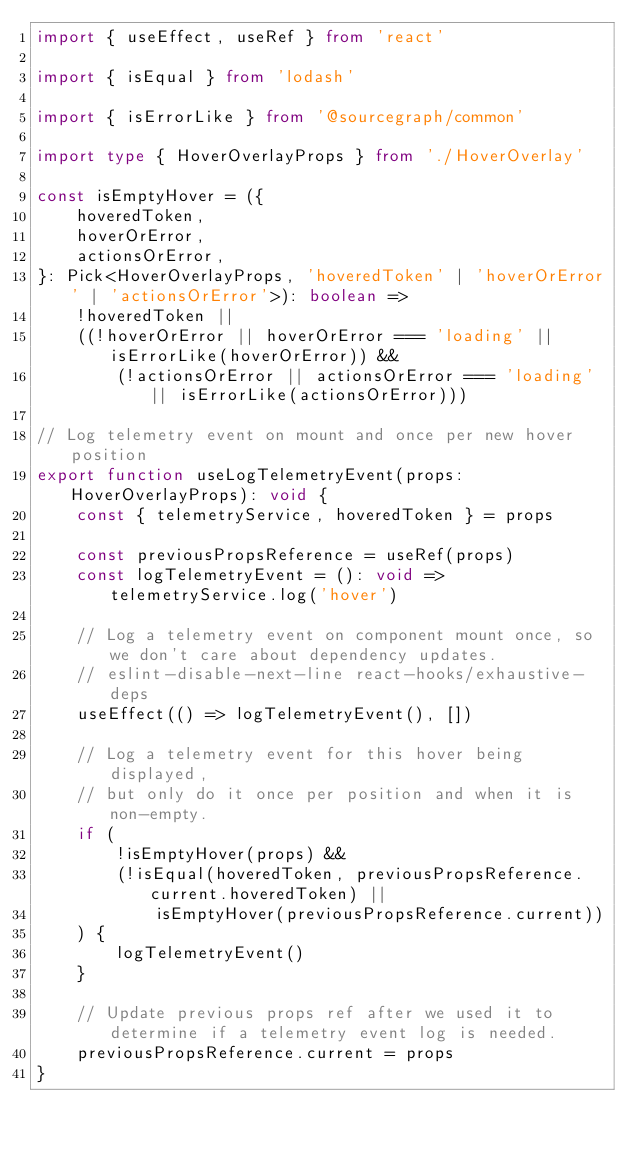Convert code to text. <code><loc_0><loc_0><loc_500><loc_500><_TypeScript_>import { useEffect, useRef } from 'react'

import { isEqual } from 'lodash'

import { isErrorLike } from '@sourcegraph/common'

import type { HoverOverlayProps } from './HoverOverlay'

const isEmptyHover = ({
    hoveredToken,
    hoverOrError,
    actionsOrError,
}: Pick<HoverOverlayProps, 'hoveredToken' | 'hoverOrError' | 'actionsOrError'>): boolean =>
    !hoveredToken ||
    ((!hoverOrError || hoverOrError === 'loading' || isErrorLike(hoverOrError)) &&
        (!actionsOrError || actionsOrError === 'loading' || isErrorLike(actionsOrError)))

// Log telemetry event on mount and once per new hover position
export function useLogTelemetryEvent(props: HoverOverlayProps): void {
    const { telemetryService, hoveredToken } = props

    const previousPropsReference = useRef(props)
    const logTelemetryEvent = (): void => telemetryService.log('hover')

    // Log a telemetry event on component mount once, so we don't care about dependency updates.
    // eslint-disable-next-line react-hooks/exhaustive-deps
    useEffect(() => logTelemetryEvent(), [])

    // Log a telemetry event for this hover being displayed,
    // but only do it once per position and when it is non-empty.
    if (
        !isEmptyHover(props) &&
        (!isEqual(hoveredToken, previousPropsReference.current.hoveredToken) ||
            isEmptyHover(previousPropsReference.current))
    ) {
        logTelemetryEvent()
    }

    // Update previous props ref after we used it to determine if a telemetry event log is needed.
    previousPropsReference.current = props
}
</code> 